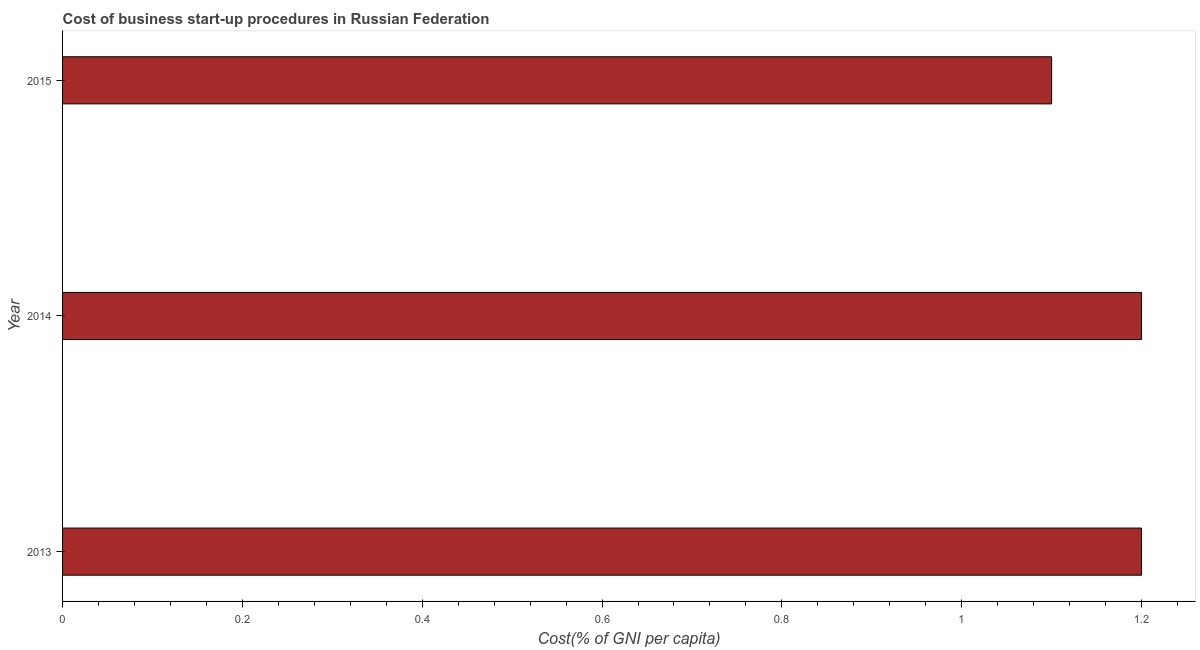Does the graph contain any zero values?
Your answer should be compact. No. What is the title of the graph?
Make the answer very short. Cost of business start-up procedures in Russian Federation. What is the label or title of the X-axis?
Your answer should be very brief. Cost(% of GNI per capita). What is the cost of business startup procedures in 2013?
Ensure brevity in your answer.  1.2. Across all years, what is the minimum cost of business startup procedures?
Give a very brief answer. 1.1. In which year was the cost of business startup procedures maximum?
Make the answer very short. 2013. In which year was the cost of business startup procedures minimum?
Provide a succinct answer. 2015. What is the average cost of business startup procedures per year?
Provide a succinct answer. 1.17. What is the median cost of business startup procedures?
Make the answer very short. 1.2. Do a majority of the years between 2015 and 2014 (inclusive) have cost of business startup procedures greater than 0.16 %?
Offer a very short reply. No. What is the ratio of the cost of business startup procedures in 2013 to that in 2015?
Your response must be concise. 1.09. Is the cost of business startup procedures in 2014 less than that in 2015?
Provide a succinct answer. No. Is the difference between the cost of business startup procedures in 2013 and 2015 greater than the difference between any two years?
Offer a very short reply. Yes. What is the difference between the highest and the second highest cost of business startup procedures?
Keep it short and to the point. 0. How many bars are there?
Your answer should be very brief. 3. Are all the bars in the graph horizontal?
Provide a succinct answer. Yes. What is the difference between the Cost(% of GNI per capita) in 2014 and 2015?
Ensure brevity in your answer.  0.1. What is the ratio of the Cost(% of GNI per capita) in 2013 to that in 2015?
Make the answer very short. 1.09. What is the ratio of the Cost(% of GNI per capita) in 2014 to that in 2015?
Your response must be concise. 1.09. 